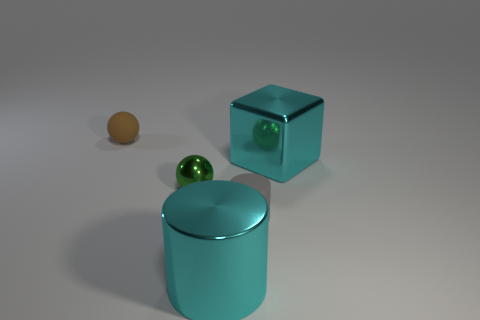Add 4 large cyan metal objects. How many objects exist? 9 Subtract all cubes. How many objects are left? 4 Add 1 big cyan cylinders. How many big cyan cylinders are left? 2 Add 4 gray matte cylinders. How many gray matte cylinders exist? 5 Subtract 0 yellow cylinders. How many objects are left? 5 Subtract all cubes. Subtract all green metal spheres. How many objects are left? 3 